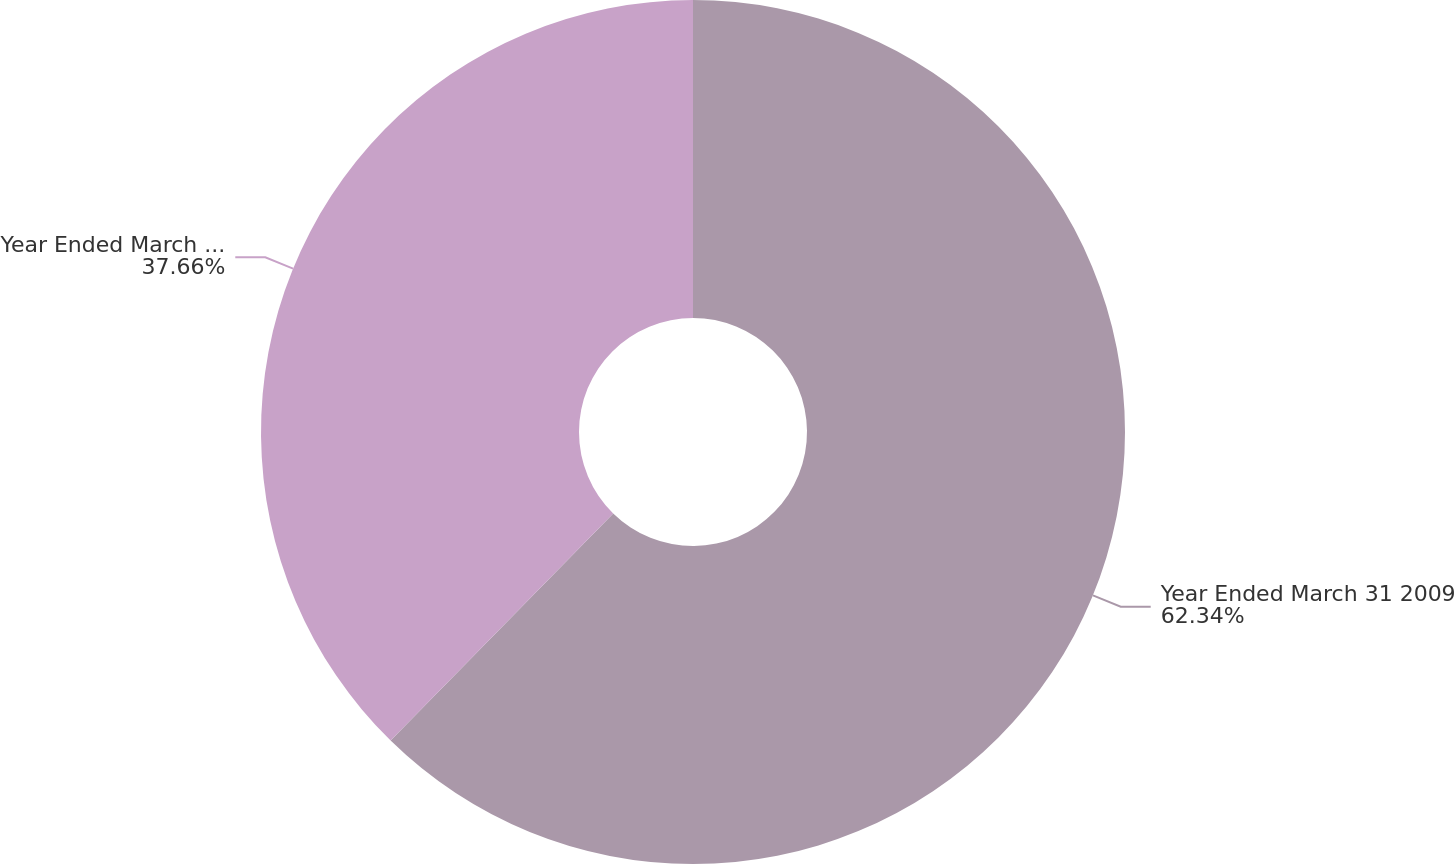Convert chart. <chart><loc_0><loc_0><loc_500><loc_500><pie_chart><fcel>Year Ended March 31 2009<fcel>Year Ended March 31 2008<nl><fcel>62.34%<fcel>37.66%<nl></chart> 